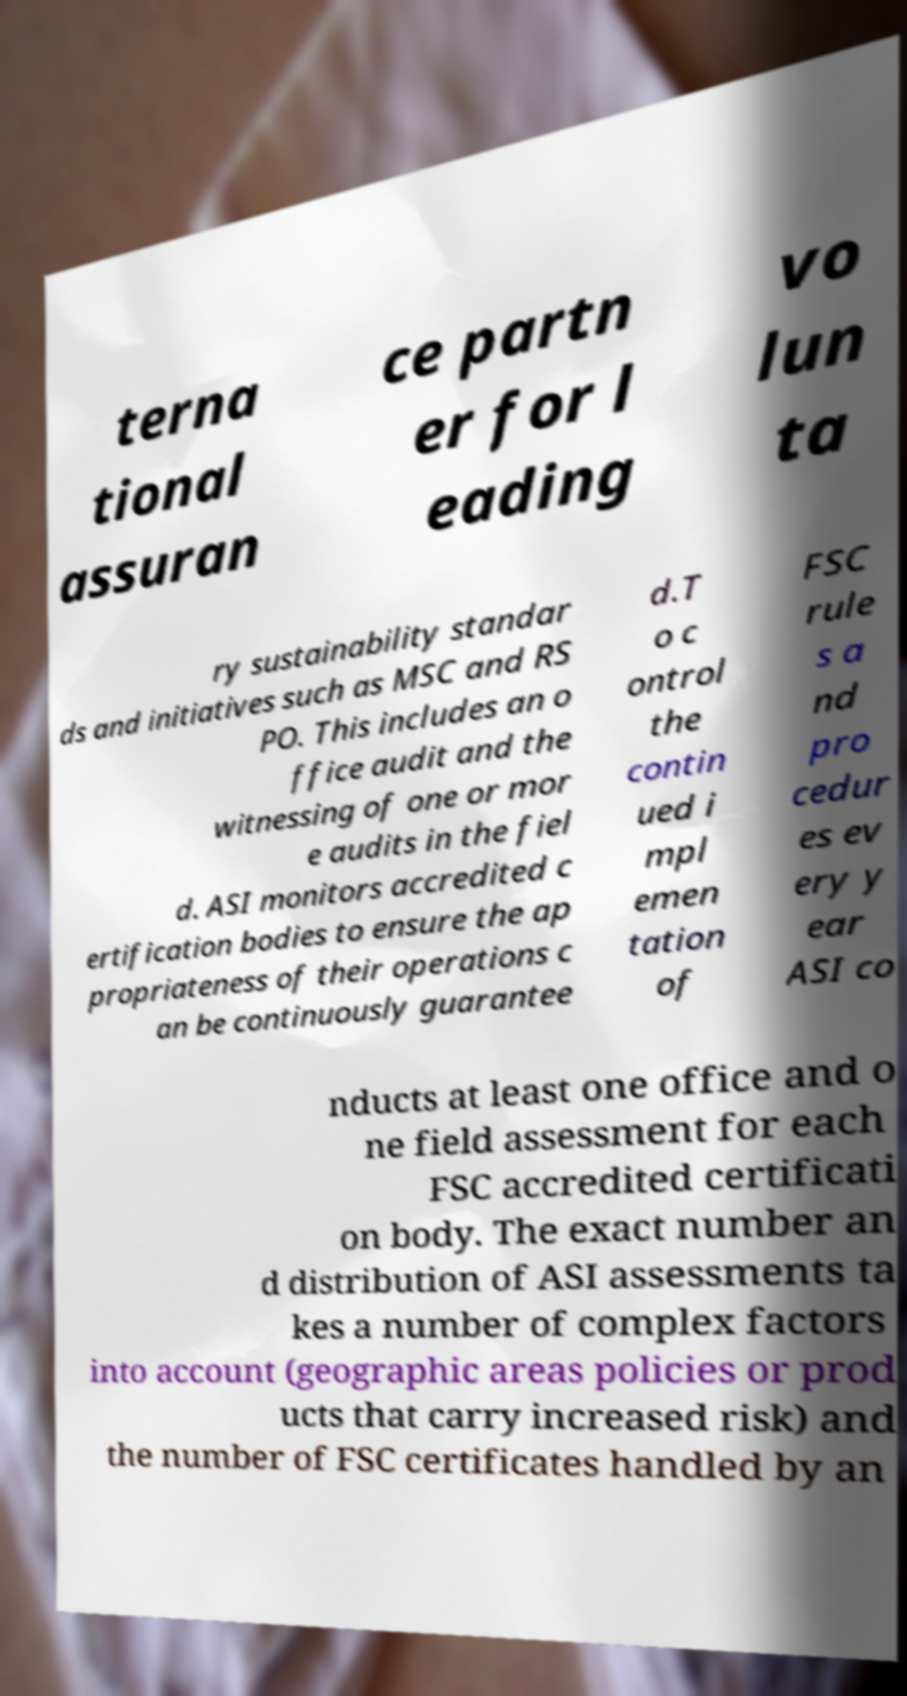Could you extract and type out the text from this image? terna tional assuran ce partn er for l eading vo lun ta ry sustainability standar ds and initiatives such as MSC and RS PO. This includes an o ffice audit and the witnessing of one or mor e audits in the fiel d. ASI monitors accredited c ertification bodies to ensure the ap propriateness of their operations c an be continuously guarantee d.T o c ontrol the contin ued i mpl emen tation of FSC rule s a nd pro cedur es ev ery y ear ASI co nducts at least one office and o ne field assessment for each FSC accredited certificati on body. The exact number an d distribution of ASI assessments ta kes a number of complex factors into account (geographic areas policies or prod ucts that carry increased risk) and the number of FSC certificates handled by an 